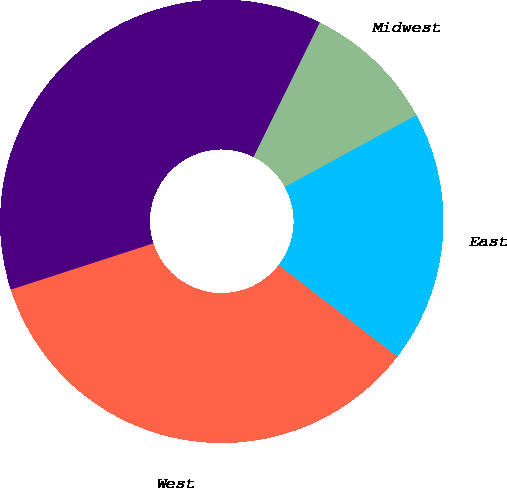Convert chart to OTSL. <chart><loc_0><loc_0><loc_500><loc_500><pie_chart><fcel>East<fcel>Midwest<fcel>Southeast<fcel>West<nl><fcel>18.41%<fcel>9.77%<fcel>37.28%<fcel>34.55%<nl></chart> 